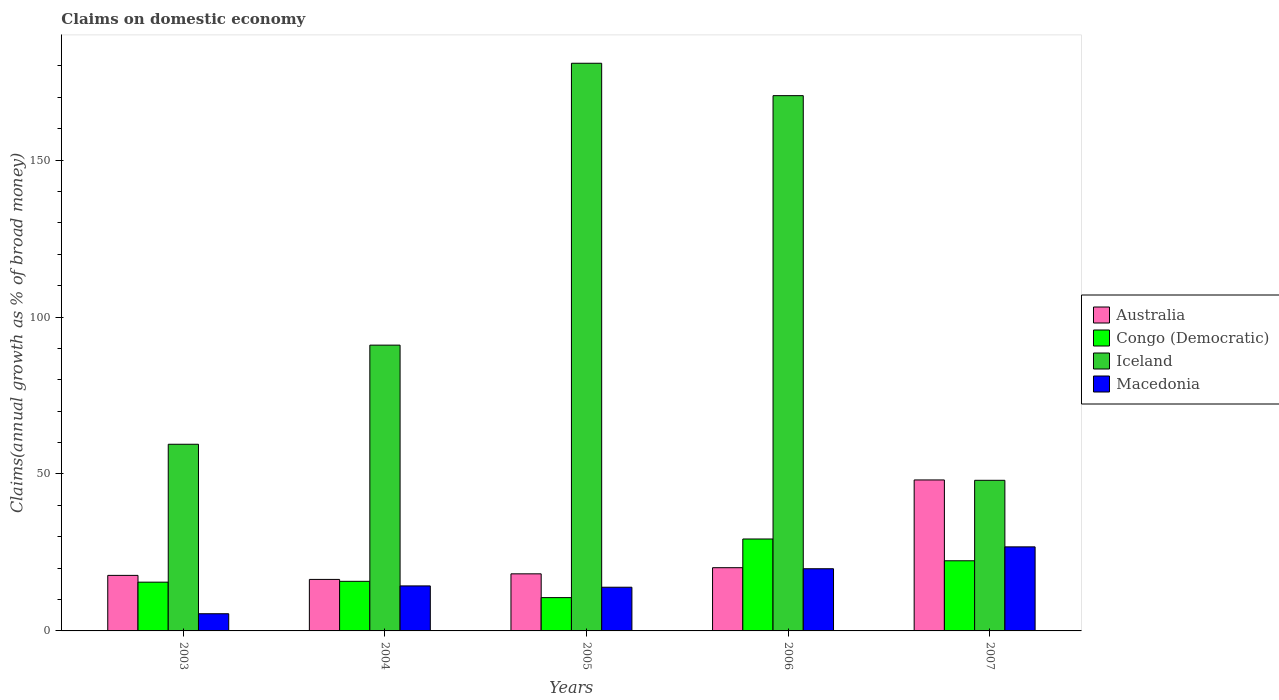How many different coloured bars are there?
Offer a terse response. 4. Are the number of bars per tick equal to the number of legend labels?
Provide a succinct answer. Yes. How many bars are there on the 3rd tick from the left?
Keep it short and to the point. 4. In how many cases, is the number of bars for a given year not equal to the number of legend labels?
Provide a short and direct response. 0. What is the percentage of broad money claimed on domestic economy in Australia in 2004?
Keep it short and to the point. 16.41. Across all years, what is the maximum percentage of broad money claimed on domestic economy in Australia?
Give a very brief answer. 48.1. Across all years, what is the minimum percentage of broad money claimed on domestic economy in Macedonia?
Your answer should be very brief. 5.47. In which year was the percentage of broad money claimed on domestic economy in Australia maximum?
Offer a terse response. 2007. What is the total percentage of broad money claimed on domestic economy in Australia in the graph?
Offer a terse response. 120.53. What is the difference between the percentage of broad money claimed on domestic economy in Macedonia in 2004 and that in 2007?
Offer a very short reply. -12.44. What is the difference between the percentage of broad money claimed on domestic economy in Iceland in 2006 and the percentage of broad money claimed on domestic economy in Macedonia in 2004?
Your answer should be compact. 156.18. What is the average percentage of broad money claimed on domestic economy in Congo (Democratic) per year?
Ensure brevity in your answer.  18.72. In the year 2004, what is the difference between the percentage of broad money claimed on domestic economy in Congo (Democratic) and percentage of broad money claimed on domestic economy in Iceland?
Make the answer very short. -75.24. What is the ratio of the percentage of broad money claimed on domestic economy in Australia in 2005 to that in 2006?
Provide a succinct answer. 0.9. Is the percentage of broad money claimed on domestic economy in Macedonia in 2005 less than that in 2006?
Your answer should be very brief. Yes. What is the difference between the highest and the second highest percentage of broad money claimed on domestic economy in Macedonia?
Offer a terse response. 6.97. What is the difference between the highest and the lowest percentage of broad money claimed on domestic economy in Congo (Democratic)?
Your answer should be compact. 18.68. Is the sum of the percentage of broad money claimed on domestic economy in Macedonia in 2004 and 2005 greater than the maximum percentage of broad money claimed on domestic economy in Iceland across all years?
Make the answer very short. No. What does the 2nd bar from the left in 2005 represents?
Keep it short and to the point. Congo (Democratic). What does the 1st bar from the right in 2005 represents?
Ensure brevity in your answer.  Macedonia. How many bars are there?
Provide a succinct answer. 20. Are all the bars in the graph horizontal?
Your response must be concise. No. How many years are there in the graph?
Your answer should be compact. 5. What is the difference between two consecutive major ticks on the Y-axis?
Your response must be concise. 50. Are the values on the major ticks of Y-axis written in scientific E-notation?
Provide a short and direct response. No. Does the graph contain grids?
Your response must be concise. No. How many legend labels are there?
Your answer should be compact. 4. What is the title of the graph?
Provide a short and direct response. Claims on domestic economy. What is the label or title of the Y-axis?
Offer a terse response. Claims(annual growth as % of broad money). What is the Claims(annual growth as % of broad money) in Australia in 2003?
Keep it short and to the point. 17.69. What is the Claims(annual growth as % of broad money) in Congo (Democratic) in 2003?
Give a very brief answer. 15.53. What is the Claims(annual growth as % of broad money) in Iceland in 2003?
Keep it short and to the point. 59.47. What is the Claims(annual growth as % of broad money) in Macedonia in 2003?
Offer a very short reply. 5.47. What is the Claims(annual growth as % of broad money) in Australia in 2004?
Ensure brevity in your answer.  16.41. What is the Claims(annual growth as % of broad money) in Congo (Democratic) in 2004?
Provide a short and direct response. 15.8. What is the Claims(annual growth as % of broad money) in Iceland in 2004?
Ensure brevity in your answer.  91.04. What is the Claims(annual growth as % of broad money) of Macedonia in 2004?
Ensure brevity in your answer.  14.34. What is the Claims(annual growth as % of broad money) in Australia in 2005?
Provide a short and direct response. 18.18. What is the Claims(annual growth as % of broad money) of Congo (Democratic) in 2005?
Your answer should be compact. 10.61. What is the Claims(annual growth as % of broad money) of Iceland in 2005?
Offer a terse response. 180.84. What is the Claims(annual growth as % of broad money) of Macedonia in 2005?
Your response must be concise. 13.92. What is the Claims(annual growth as % of broad money) in Australia in 2006?
Give a very brief answer. 20.14. What is the Claims(annual growth as % of broad money) of Congo (Democratic) in 2006?
Your answer should be compact. 29.29. What is the Claims(annual growth as % of broad money) of Iceland in 2006?
Give a very brief answer. 170.52. What is the Claims(annual growth as % of broad money) in Macedonia in 2006?
Provide a short and direct response. 19.81. What is the Claims(annual growth as % of broad money) of Australia in 2007?
Your answer should be very brief. 48.1. What is the Claims(annual growth as % of broad money) in Congo (Democratic) in 2007?
Make the answer very short. 22.35. What is the Claims(annual growth as % of broad money) in Iceland in 2007?
Provide a succinct answer. 47.98. What is the Claims(annual growth as % of broad money) of Macedonia in 2007?
Provide a short and direct response. 26.78. Across all years, what is the maximum Claims(annual growth as % of broad money) in Australia?
Offer a very short reply. 48.1. Across all years, what is the maximum Claims(annual growth as % of broad money) in Congo (Democratic)?
Provide a succinct answer. 29.29. Across all years, what is the maximum Claims(annual growth as % of broad money) of Iceland?
Offer a very short reply. 180.84. Across all years, what is the maximum Claims(annual growth as % of broad money) of Macedonia?
Offer a terse response. 26.78. Across all years, what is the minimum Claims(annual growth as % of broad money) of Australia?
Your answer should be compact. 16.41. Across all years, what is the minimum Claims(annual growth as % of broad money) of Congo (Democratic)?
Keep it short and to the point. 10.61. Across all years, what is the minimum Claims(annual growth as % of broad money) in Iceland?
Keep it short and to the point. 47.98. Across all years, what is the minimum Claims(annual growth as % of broad money) in Macedonia?
Offer a terse response. 5.47. What is the total Claims(annual growth as % of broad money) of Australia in the graph?
Ensure brevity in your answer.  120.53. What is the total Claims(annual growth as % of broad money) in Congo (Democratic) in the graph?
Your response must be concise. 93.58. What is the total Claims(annual growth as % of broad money) in Iceland in the graph?
Give a very brief answer. 549.85. What is the total Claims(annual growth as % of broad money) in Macedonia in the graph?
Give a very brief answer. 80.31. What is the difference between the Claims(annual growth as % of broad money) in Australia in 2003 and that in 2004?
Give a very brief answer. 1.28. What is the difference between the Claims(annual growth as % of broad money) of Congo (Democratic) in 2003 and that in 2004?
Make the answer very short. -0.27. What is the difference between the Claims(annual growth as % of broad money) of Iceland in 2003 and that in 2004?
Offer a very short reply. -31.58. What is the difference between the Claims(annual growth as % of broad money) in Macedonia in 2003 and that in 2004?
Offer a terse response. -8.86. What is the difference between the Claims(annual growth as % of broad money) in Australia in 2003 and that in 2005?
Provide a succinct answer. -0.49. What is the difference between the Claims(annual growth as % of broad money) in Congo (Democratic) in 2003 and that in 2005?
Your response must be concise. 4.93. What is the difference between the Claims(annual growth as % of broad money) in Iceland in 2003 and that in 2005?
Your answer should be very brief. -121.37. What is the difference between the Claims(annual growth as % of broad money) of Macedonia in 2003 and that in 2005?
Provide a succinct answer. -8.44. What is the difference between the Claims(annual growth as % of broad money) in Australia in 2003 and that in 2006?
Your response must be concise. -2.45. What is the difference between the Claims(annual growth as % of broad money) of Congo (Democratic) in 2003 and that in 2006?
Offer a very short reply. -13.75. What is the difference between the Claims(annual growth as % of broad money) of Iceland in 2003 and that in 2006?
Your answer should be compact. -111.05. What is the difference between the Claims(annual growth as % of broad money) in Macedonia in 2003 and that in 2006?
Provide a succinct answer. -14.34. What is the difference between the Claims(annual growth as % of broad money) in Australia in 2003 and that in 2007?
Provide a short and direct response. -30.4. What is the difference between the Claims(annual growth as % of broad money) of Congo (Democratic) in 2003 and that in 2007?
Your answer should be compact. -6.81. What is the difference between the Claims(annual growth as % of broad money) in Iceland in 2003 and that in 2007?
Provide a succinct answer. 11.49. What is the difference between the Claims(annual growth as % of broad money) of Macedonia in 2003 and that in 2007?
Provide a succinct answer. -21.3. What is the difference between the Claims(annual growth as % of broad money) in Australia in 2004 and that in 2005?
Offer a very short reply. -1.77. What is the difference between the Claims(annual growth as % of broad money) in Congo (Democratic) in 2004 and that in 2005?
Offer a terse response. 5.19. What is the difference between the Claims(annual growth as % of broad money) of Iceland in 2004 and that in 2005?
Give a very brief answer. -89.79. What is the difference between the Claims(annual growth as % of broad money) of Macedonia in 2004 and that in 2005?
Keep it short and to the point. 0.42. What is the difference between the Claims(annual growth as % of broad money) of Australia in 2004 and that in 2006?
Your answer should be compact. -3.73. What is the difference between the Claims(annual growth as % of broad money) in Congo (Democratic) in 2004 and that in 2006?
Offer a very short reply. -13.49. What is the difference between the Claims(annual growth as % of broad money) of Iceland in 2004 and that in 2006?
Your response must be concise. -79.47. What is the difference between the Claims(annual growth as % of broad money) of Macedonia in 2004 and that in 2006?
Keep it short and to the point. -5.47. What is the difference between the Claims(annual growth as % of broad money) of Australia in 2004 and that in 2007?
Provide a succinct answer. -31.69. What is the difference between the Claims(annual growth as % of broad money) in Congo (Democratic) in 2004 and that in 2007?
Ensure brevity in your answer.  -6.55. What is the difference between the Claims(annual growth as % of broad money) in Iceland in 2004 and that in 2007?
Your response must be concise. 43.06. What is the difference between the Claims(annual growth as % of broad money) in Macedonia in 2004 and that in 2007?
Give a very brief answer. -12.44. What is the difference between the Claims(annual growth as % of broad money) of Australia in 2005 and that in 2006?
Offer a very short reply. -1.96. What is the difference between the Claims(annual growth as % of broad money) of Congo (Democratic) in 2005 and that in 2006?
Give a very brief answer. -18.68. What is the difference between the Claims(annual growth as % of broad money) of Iceland in 2005 and that in 2006?
Your answer should be very brief. 10.32. What is the difference between the Claims(annual growth as % of broad money) in Macedonia in 2005 and that in 2006?
Offer a very short reply. -5.89. What is the difference between the Claims(annual growth as % of broad money) of Australia in 2005 and that in 2007?
Provide a succinct answer. -29.91. What is the difference between the Claims(annual growth as % of broad money) of Congo (Democratic) in 2005 and that in 2007?
Make the answer very short. -11.74. What is the difference between the Claims(annual growth as % of broad money) in Iceland in 2005 and that in 2007?
Your answer should be compact. 132.86. What is the difference between the Claims(annual growth as % of broad money) in Macedonia in 2005 and that in 2007?
Provide a short and direct response. -12.86. What is the difference between the Claims(annual growth as % of broad money) of Australia in 2006 and that in 2007?
Your answer should be very brief. -27.95. What is the difference between the Claims(annual growth as % of broad money) in Congo (Democratic) in 2006 and that in 2007?
Offer a very short reply. 6.94. What is the difference between the Claims(annual growth as % of broad money) in Iceland in 2006 and that in 2007?
Provide a succinct answer. 122.54. What is the difference between the Claims(annual growth as % of broad money) of Macedonia in 2006 and that in 2007?
Make the answer very short. -6.97. What is the difference between the Claims(annual growth as % of broad money) of Australia in 2003 and the Claims(annual growth as % of broad money) of Congo (Democratic) in 2004?
Make the answer very short. 1.89. What is the difference between the Claims(annual growth as % of broad money) in Australia in 2003 and the Claims(annual growth as % of broad money) in Iceland in 2004?
Make the answer very short. -73.35. What is the difference between the Claims(annual growth as % of broad money) in Australia in 2003 and the Claims(annual growth as % of broad money) in Macedonia in 2004?
Offer a terse response. 3.36. What is the difference between the Claims(annual growth as % of broad money) of Congo (Democratic) in 2003 and the Claims(annual growth as % of broad money) of Iceland in 2004?
Offer a very short reply. -75.51. What is the difference between the Claims(annual growth as % of broad money) in Congo (Democratic) in 2003 and the Claims(annual growth as % of broad money) in Macedonia in 2004?
Offer a terse response. 1.2. What is the difference between the Claims(annual growth as % of broad money) in Iceland in 2003 and the Claims(annual growth as % of broad money) in Macedonia in 2004?
Offer a very short reply. 45.13. What is the difference between the Claims(annual growth as % of broad money) of Australia in 2003 and the Claims(annual growth as % of broad money) of Congo (Democratic) in 2005?
Offer a terse response. 7.09. What is the difference between the Claims(annual growth as % of broad money) in Australia in 2003 and the Claims(annual growth as % of broad money) in Iceland in 2005?
Offer a terse response. -163.14. What is the difference between the Claims(annual growth as % of broad money) of Australia in 2003 and the Claims(annual growth as % of broad money) of Macedonia in 2005?
Make the answer very short. 3.78. What is the difference between the Claims(annual growth as % of broad money) in Congo (Democratic) in 2003 and the Claims(annual growth as % of broad money) in Iceland in 2005?
Keep it short and to the point. -165.3. What is the difference between the Claims(annual growth as % of broad money) of Congo (Democratic) in 2003 and the Claims(annual growth as % of broad money) of Macedonia in 2005?
Provide a succinct answer. 1.62. What is the difference between the Claims(annual growth as % of broad money) of Iceland in 2003 and the Claims(annual growth as % of broad money) of Macedonia in 2005?
Ensure brevity in your answer.  45.55. What is the difference between the Claims(annual growth as % of broad money) of Australia in 2003 and the Claims(annual growth as % of broad money) of Congo (Democratic) in 2006?
Your answer should be compact. -11.59. What is the difference between the Claims(annual growth as % of broad money) of Australia in 2003 and the Claims(annual growth as % of broad money) of Iceland in 2006?
Provide a succinct answer. -152.82. What is the difference between the Claims(annual growth as % of broad money) of Australia in 2003 and the Claims(annual growth as % of broad money) of Macedonia in 2006?
Your response must be concise. -2.11. What is the difference between the Claims(annual growth as % of broad money) of Congo (Democratic) in 2003 and the Claims(annual growth as % of broad money) of Iceland in 2006?
Your answer should be compact. -154.98. What is the difference between the Claims(annual growth as % of broad money) of Congo (Democratic) in 2003 and the Claims(annual growth as % of broad money) of Macedonia in 2006?
Your response must be concise. -4.28. What is the difference between the Claims(annual growth as % of broad money) of Iceland in 2003 and the Claims(annual growth as % of broad money) of Macedonia in 2006?
Keep it short and to the point. 39.66. What is the difference between the Claims(annual growth as % of broad money) of Australia in 2003 and the Claims(annual growth as % of broad money) of Congo (Democratic) in 2007?
Your response must be concise. -4.65. What is the difference between the Claims(annual growth as % of broad money) of Australia in 2003 and the Claims(annual growth as % of broad money) of Iceland in 2007?
Provide a succinct answer. -30.29. What is the difference between the Claims(annual growth as % of broad money) in Australia in 2003 and the Claims(annual growth as % of broad money) in Macedonia in 2007?
Give a very brief answer. -9.08. What is the difference between the Claims(annual growth as % of broad money) in Congo (Democratic) in 2003 and the Claims(annual growth as % of broad money) in Iceland in 2007?
Your response must be concise. -32.45. What is the difference between the Claims(annual growth as % of broad money) of Congo (Democratic) in 2003 and the Claims(annual growth as % of broad money) of Macedonia in 2007?
Keep it short and to the point. -11.24. What is the difference between the Claims(annual growth as % of broad money) in Iceland in 2003 and the Claims(annual growth as % of broad money) in Macedonia in 2007?
Your answer should be very brief. 32.69. What is the difference between the Claims(annual growth as % of broad money) in Australia in 2004 and the Claims(annual growth as % of broad money) in Congo (Democratic) in 2005?
Provide a succinct answer. 5.8. What is the difference between the Claims(annual growth as % of broad money) in Australia in 2004 and the Claims(annual growth as % of broad money) in Iceland in 2005?
Provide a succinct answer. -164.43. What is the difference between the Claims(annual growth as % of broad money) of Australia in 2004 and the Claims(annual growth as % of broad money) of Macedonia in 2005?
Provide a short and direct response. 2.49. What is the difference between the Claims(annual growth as % of broad money) in Congo (Democratic) in 2004 and the Claims(annual growth as % of broad money) in Iceland in 2005?
Your answer should be very brief. -165.04. What is the difference between the Claims(annual growth as % of broad money) in Congo (Democratic) in 2004 and the Claims(annual growth as % of broad money) in Macedonia in 2005?
Provide a short and direct response. 1.88. What is the difference between the Claims(annual growth as % of broad money) of Iceland in 2004 and the Claims(annual growth as % of broad money) of Macedonia in 2005?
Provide a succinct answer. 77.13. What is the difference between the Claims(annual growth as % of broad money) of Australia in 2004 and the Claims(annual growth as % of broad money) of Congo (Democratic) in 2006?
Ensure brevity in your answer.  -12.88. What is the difference between the Claims(annual growth as % of broad money) in Australia in 2004 and the Claims(annual growth as % of broad money) in Iceland in 2006?
Keep it short and to the point. -154.11. What is the difference between the Claims(annual growth as % of broad money) in Australia in 2004 and the Claims(annual growth as % of broad money) in Macedonia in 2006?
Your response must be concise. -3.4. What is the difference between the Claims(annual growth as % of broad money) of Congo (Democratic) in 2004 and the Claims(annual growth as % of broad money) of Iceland in 2006?
Provide a succinct answer. -154.72. What is the difference between the Claims(annual growth as % of broad money) in Congo (Democratic) in 2004 and the Claims(annual growth as % of broad money) in Macedonia in 2006?
Offer a terse response. -4.01. What is the difference between the Claims(annual growth as % of broad money) of Iceland in 2004 and the Claims(annual growth as % of broad money) of Macedonia in 2006?
Your answer should be compact. 71.24. What is the difference between the Claims(annual growth as % of broad money) of Australia in 2004 and the Claims(annual growth as % of broad money) of Congo (Democratic) in 2007?
Provide a short and direct response. -5.94. What is the difference between the Claims(annual growth as % of broad money) in Australia in 2004 and the Claims(annual growth as % of broad money) in Iceland in 2007?
Your answer should be very brief. -31.57. What is the difference between the Claims(annual growth as % of broad money) in Australia in 2004 and the Claims(annual growth as % of broad money) in Macedonia in 2007?
Provide a succinct answer. -10.37. What is the difference between the Claims(annual growth as % of broad money) of Congo (Democratic) in 2004 and the Claims(annual growth as % of broad money) of Iceland in 2007?
Offer a terse response. -32.18. What is the difference between the Claims(annual growth as % of broad money) in Congo (Democratic) in 2004 and the Claims(annual growth as % of broad money) in Macedonia in 2007?
Make the answer very short. -10.98. What is the difference between the Claims(annual growth as % of broad money) of Iceland in 2004 and the Claims(annual growth as % of broad money) of Macedonia in 2007?
Offer a very short reply. 64.27. What is the difference between the Claims(annual growth as % of broad money) in Australia in 2005 and the Claims(annual growth as % of broad money) in Congo (Democratic) in 2006?
Keep it short and to the point. -11.1. What is the difference between the Claims(annual growth as % of broad money) of Australia in 2005 and the Claims(annual growth as % of broad money) of Iceland in 2006?
Offer a terse response. -152.34. What is the difference between the Claims(annual growth as % of broad money) of Australia in 2005 and the Claims(annual growth as % of broad money) of Macedonia in 2006?
Your response must be concise. -1.63. What is the difference between the Claims(annual growth as % of broad money) of Congo (Democratic) in 2005 and the Claims(annual growth as % of broad money) of Iceland in 2006?
Offer a terse response. -159.91. What is the difference between the Claims(annual growth as % of broad money) in Congo (Democratic) in 2005 and the Claims(annual growth as % of broad money) in Macedonia in 2006?
Keep it short and to the point. -9.2. What is the difference between the Claims(annual growth as % of broad money) of Iceland in 2005 and the Claims(annual growth as % of broad money) of Macedonia in 2006?
Your answer should be very brief. 161.03. What is the difference between the Claims(annual growth as % of broad money) in Australia in 2005 and the Claims(annual growth as % of broad money) in Congo (Democratic) in 2007?
Ensure brevity in your answer.  -4.16. What is the difference between the Claims(annual growth as % of broad money) in Australia in 2005 and the Claims(annual growth as % of broad money) in Iceland in 2007?
Offer a very short reply. -29.8. What is the difference between the Claims(annual growth as % of broad money) of Australia in 2005 and the Claims(annual growth as % of broad money) of Macedonia in 2007?
Keep it short and to the point. -8.59. What is the difference between the Claims(annual growth as % of broad money) in Congo (Democratic) in 2005 and the Claims(annual growth as % of broad money) in Iceland in 2007?
Provide a short and direct response. -37.37. What is the difference between the Claims(annual growth as % of broad money) in Congo (Democratic) in 2005 and the Claims(annual growth as % of broad money) in Macedonia in 2007?
Offer a terse response. -16.17. What is the difference between the Claims(annual growth as % of broad money) in Iceland in 2005 and the Claims(annual growth as % of broad money) in Macedonia in 2007?
Provide a short and direct response. 154.06. What is the difference between the Claims(annual growth as % of broad money) of Australia in 2006 and the Claims(annual growth as % of broad money) of Congo (Democratic) in 2007?
Make the answer very short. -2.21. What is the difference between the Claims(annual growth as % of broad money) of Australia in 2006 and the Claims(annual growth as % of broad money) of Iceland in 2007?
Give a very brief answer. -27.84. What is the difference between the Claims(annual growth as % of broad money) in Australia in 2006 and the Claims(annual growth as % of broad money) in Macedonia in 2007?
Provide a succinct answer. -6.63. What is the difference between the Claims(annual growth as % of broad money) of Congo (Democratic) in 2006 and the Claims(annual growth as % of broad money) of Iceland in 2007?
Offer a very short reply. -18.69. What is the difference between the Claims(annual growth as % of broad money) of Congo (Democratic) in 2006 and the Claims(annual growth as % of broad money) of Macedonia in 2007?
Your answer should be compact. 2.51. What is the difference between the Claims(annual growth as % of broad money) of Iceland in 2006 and the Claims(annual growth as % of broad money) of Macedonia in 2007?
Your response must be concise. 143.74. What is the average Claims(annual growth as % of broad money) in Australia per year?
Your response must be concise. 24.11. What is the average Claims(annual growth as % of broad money) in Congo (Democratic) per year?
Keep it short and to the point. 18.72. What is the average Claims(annual growth as % of broad money) of Iceland per year?
Offer a very short reply. 109.97. What is the average Claims(annual growth as % of broad money) of Macedonia per year?
Your answer should be compact. 16.06. In the year 2003, what is the difference between the Claims(annual growth as % of broad money) in Australia and Claims(annual growth as % of broad money) in Congo (Democratic)?
Your response must be concise. 2.16. In the year 2003, what is the difference between the Claims(annual growth as % of broad money) in Australia and Claims(annual growth as % of broad money) in Iceland?
Offer a very short reply. -41.77. In the year 2003, what is the difference between the Claims(annual growth as % of broad money) of Australia and Claims(annual growth as % of broad money) of Macedonia?
Provide a succinct answer. 12.22. In the year 2003, what is the difference between the Claims(annual growth as % of broad money) of Congo (Democratic) and Claims(annual growth as % of broad money) of Iceland?
Your answer should be compact. -43.93. In the year 2003, what is the difference between the Claims(annual growth as % of broad money) in Congo (Democratic) and Claims(annual growth as % of broad money) in Macedonia?
Ensure brevity in your answer.  10.06. In the year 2003, what is the difference between the Claims(annual growth as % of broad money) of Iceland and Claims(annual growth as % of broad money) of Macedonia?
Provide a short and direct response. 53.99. In the year 2004, what is the difference between the Claims(annual growth as % of broad money) of Australia and Claims(annual growth as % of broad money) of Congo (Democratic)?
Offer a very short reply. 0.61. In the year 2004, what is the difference between the Claims(annual growth as % of broad money) of Australia and Claims(annual growth as % of broad money) of Iceland?
Give a very brief answer. -74.63. In the year 2004, what is the difference between the Claims(annual growth as % of broad money) in Australia and Claims(annual growth as % of broad money) in Macedonia?
Offer a very short reply. 2.07. In the year 2004, what is the difference between the Claims(annual growth as % of broad money) in Congo (Democratic) and Claims(annual growth as % of broad money) in Iceland?
Offer a terse response. -75.24. In the year 2004, what is the difference between the Claims(annual growth as % of broad money) of Congo (Democratic) and Claims(annual growth as % of broad money) of Macedonia?
Provide a short and direct response. 1.46. In the year 2004, what is the difference between the Claims(annual growth as % of broad money) in Iceland and Claims(annual growth as % of broad money) in Macedonia?
Your response must be concise. 76.71. In the year 2005, what is the difference between the Claims(annual growth as % of broad money) of Australia and Claims(annual growth as % of broad money) of Congo (Democratic)?
Give a very brief answer. 7.58. In the year 2005, what is the difference between the Claims(annual growth as % of broad money) of Australia and Claims(annual growth as % of broad money) of Iceland?
Your response must be concise. -162.65. In the year 2005, what is the difference between the Claims(annual growth as % of broad money) of Australia and Claims(annual growth as % of broad money) of Macedonia?
Your response must be concise. 4.27. In the year 2005, what is the difference between the Claims(annual growth as % of broad money) in Congo (Democratic) and Claims(annual growth as % of broad money) in Iceland?
Ensure brevity in your answer.  -170.23. In the year 2005, what is the difference between the Claims(annual growth as % of broad money) in Congo (Democratic) and Claims(annual growth as % of broad money) in Macedonia?
Make the answer very short. -3.31. In the year 2005, what is the difference between the Claims(annual growth as % of broad money) of Iceland and Claims(annual growth as % of broad money) of Macedonia?
Ensure brevity in your answer.  166.92. In the year 2006, what is the difference between the Claims(annual growth as % of broad money) in Australia and Claims(annual growth as % of broad money) in Congo (Democratic)?
Offer a very short reply. -9.14. In the year 2006, what is the difference between the Claims(annual growth as % of broad money) in Australia and Claims(annual growth as % of broad money) in Iceland?
Keep it short and to the point. -150.38. In the year 2006, what is the difference between the Claims(annual growth as % of broad money) in Australia and Claims(annual growth as % of broad money) in Macedonia?
Ensure brevity in your answer.  0.33. In the year 2006, what is the difference between the Claims(annual growth as % of broad money) in Congo (Democratic) and Claims(annual growth as % of broad money) in Iceland?
Provide a short and direct response. -141.23. In the year 2006, what is the difference between the Claims(annual growth as % of broad money) of Congo (Democratic) and Claims(annual growth as % of broad money) of Macedonia?
Provide a short and direct response. 9.48. In the year 2006, what is the difference between the Claims(annual growth as % of broad money) in Iceland and Claims(annual growth as % of broad money) in Macedonia?
Ensure brevity in your answer.  150.71. In the year 2007, what is the difference between the Claims(annual growth as % of broad money) in Australia and Claims(annual growth as % of broad money) in Congo (Democratic)?
Your answer should be very brief. 25.75. In the year 2007, what is the difference between the Claims(annual growth as % of broad money) in Australia and Claims(annual growth as % of broad money) in Iceland?
Keep it short and to the point. 0.12. In the year 2007, what is the difference between the Claims(annual growth as % of broad money) in Australia and Claims(annual growth as % of broad money) in Macedonia?
Provide a short and direct response. 21.32. In the year 2007, what is the difference between the Claims(annual growth as % of broad money) in Congo (Democratic) and Claims(annual growth as % of broad money) in Iceland?
Your response must be concise. -25.63. In the year 2007, what is the difference between the Claims(annual growth as % of broad money) of Congo (Democratic) and Claims(annual growth as % of broad money) of Macedonia?
Offer a terse response. -4.43. In the year 2007, what is the difference between the Claims(annual growth as % of broad money) in Iceland and Claims(annual growth as % of broad money) in Macedonia?
Offer a terse response. 21.2. What is the ratio of the Claims(annual growth as % of broad money) in Australia in 2003 to that in 2004?
Make the answer very short. 1.08. What is the ratio of the Claims(annual growth as % of broad money) of Congo (Democratic) in 2003 to that in 2004?
Offer a very short reply. 0.98. What is the ratio of the Claims(annual growth as % of broad money) in Iceland in 2003 to that in 2004?
Keep it short and to the point. 0.65. What is the ratio of the Claims(annual growth as % of broad money) in Macedonia in 2003 to that in 2004?
Ensure brevity in your answer.  0.38. What is the ratio of the Claims(annual growth as % of broad money) of Australia in 2003 to that in 2005?
Offer a terse response. 0.97. What is the ratio of the Claims(annual growth as % of broad money) in Congo (Democratic) in 2003 to that in 2005?
Offer a terse response. 1.46. What is the ratio of the Claims(annual growth as % of broad money) in Iceland in 2003 to that in 2005?
Provide a succinct answer. 0.33. What is the ratio of the Claims(annual growth as % of broad money) in Macedonia in 2003 to that in 2005?
Your answer should be compact. 0.39. What is the ratio of the Claims(annual growth as % of broad money) in Australia in 2003 to that in 2006?
Provide a short and direct response. 0.88. What is the ratio of the Claims(annual growth as % of broad money) in Congo (Democratic) in 2003 to that in 2006?
Your answer should be compact. 0.53. What is the ratio of the Claims(annual growth as % of broad money) in Iceland in 2003 to that in 2006?
Make the answer very short. 0.35. What is the ratio of the Claims(annual growth as % of broad money) in Macedonia in 2003 to that in 2006?
Provide a succinct answer. 0.28. What is the ratio of the Claims(annual growth as % of broad money) in Australia in 2003 to that in 2007?
Provide a succinct answer. 0.37. What is the ratio of the Claims(annual growth as % of broad money) in Congo (Democratic) in 2003 to that in 2007?
Give a very brief answer. 0.7. What is the ratio of the Claims(annual growth as % of broad money) in Iceland in 2003 to that in 2007?
Keep it short and to the point. 1.24. What is the ratio of the Claims(annual growth as % of broad money) of Macedonia in 2003 to that in 2007?
Offer a terse response. 0.2. What is the ratio of the Claims(annual growth as % of broad money) of Australia in 2004 to that in 2005?
Keep it short and to the point. 0.9. What is the ratio of the Claims(annual growth as % of broad money) in Congo (Democratic) in 2004 to that in 2005?
Give a very brief answer. 1.49. What is the ratio of the Claims(annual growth as % of broad money) in Iceland in 2004 to that in 2005?
Your answer should be very brief. 0.5. What is the ratio of the Claims(annual growth as % of broad money) of Macedonia in 2004 to that in 2005?
Give a very brief answer. 1.03. What is the ratio of the Claims(annual growth as % of broad money) of Australia in 2004 to that in 2006?
Provide a short and direct response. 0.81. What is the ratio of the Claims(annual growth as % of broad money) in Congo (Democratic) in 2004 to that in 2006?
Offer a very short reply. 0.54. What is the ratio of the Claims(annual growth as % of broad money) of Iceland in 2004 to that in 2006?
Make the answer very short. 0.53. What is the ratio of the Claims(annual growth as % of broad money) of Macedonia in 2004 to that in 2006?
Your response must be concise. 0.72. What is the ratio of the Claims(annual growth as % of broad money) in Australia in 2004 to that in 2007?
Provide a succinct answer. 0.34. What is the ratio of the Claims(annual growth as % of broad money) of Congo (Democratic) in 2004 to that in 2007?
Your answer should be compact. 0.71. What is the ratio of the Claims(annual growth as % of broad money) in Iceland in 2004 to that in 2007?
Provide a short and direct response. 1.9. What is the ratio of the Claims(annual growth as % of broad money) of Macedonia in 2004 to that in 2007?
Ensure brevity in your answer.  0.54. What is the ratio of the Claims(annual growth as % of broad money) in Australia in 2005 to that in 2006?
Give a very brief answer. 0.9. What is the ratio of the Claims(annual growth as % of broad money) in Congo (Democratic) in 2005 to that in 2006?
Provide a short and direct response. 0.36. What is the ratio of the Claims(annual growth as % of broad money) of Iceland in 2005 to that in 2006?
Your answer should be compact. 1.06. What is the ratio of the Claims(annual growth as % of broad money) in Macedonia in 2005 to that in 2006?
Offer a very short reply. 0.7. What is the ratio of the Claims(annual growth as % of broad money) of Australia in 2005 to that in 2007?
Your answer should be compact. 0.38. What is the ratio of the Claims(annual growth as % of broad money) in Congo (Democratic) in 2005 to that in 2007?
Ensure brevity in your answer.  0.47. What is the ratio of the Claims(annual growth as % of broad money) of Iceland in 2005 to that in 2007?
Provide a succinct answer. 3.77. What is the ratio of the Claims(annual growth as % of broad money) in Macedonia in 2005 to that in 2007?
Ensure brevity in your answer.  0.52. What is the ratio of the Claims(annual growth as % of broad money) of Australia in 2006 to that in 2007?
Make the answer very short. 0.42. What is the ratio of the Claims(annual growth as % of broad money) of Congo (Democratic) in 2006 to that in 2007?
Give a very brief answer. 1.31. What is the ratio of the Claims(annual growth as % of broad money) of Iceland in 2006 to that in 2007?
Offer a very short reply. 3.55. What is the ratio of the Claims(annual growth as % of broad money) in Macedonia in 2006 to that in 2007?
Your answer should be compact. 0.74. What is the difference between the highest and the second highest Claims(annual growth as % of broad money) of Australia?
Keep it short and to the point. 27.95. What is the difference between the highest and the second highest Claims(annual growth as % of broad money) of Congo (Democratic)?
Your answer should be compact. 6.94. What is the difference between the highest and the second highest Claims(annual growth as % of broad money) of Iceland?
Your response must be concise. 10.32. What is the difference between the highest and the second highest Claims(annual growth as % of broad money) of Macedonia?
Ensure brevity in your answer.  6.97. What is the difference between the highest and the lowest Claims(annual growth as % of broad money) in Australia?
Make the answer very short. 31.69. What is the difference between the highest and the lowest Claims(annual growth as % of broad money) of Congo (Democratic)?
Give a very brief answer. 18.68. What is the difference between the highest and the lowest Claims(annual growth as % of broad money) in Iceland?
Your response must be concise. 132.86. What is the difference between the highest and the lowest Claims(annual growth as % of broad money) of Macedonia?
Provide a succinct answer. 21.3. 